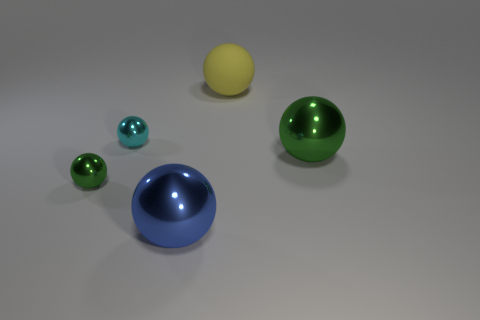What can you infer about the light source in this scene? The light source appears to be diffused and located above the spheres, as indicated by the soft shadows directly under the objects and the highlights at the top of each sphere. 